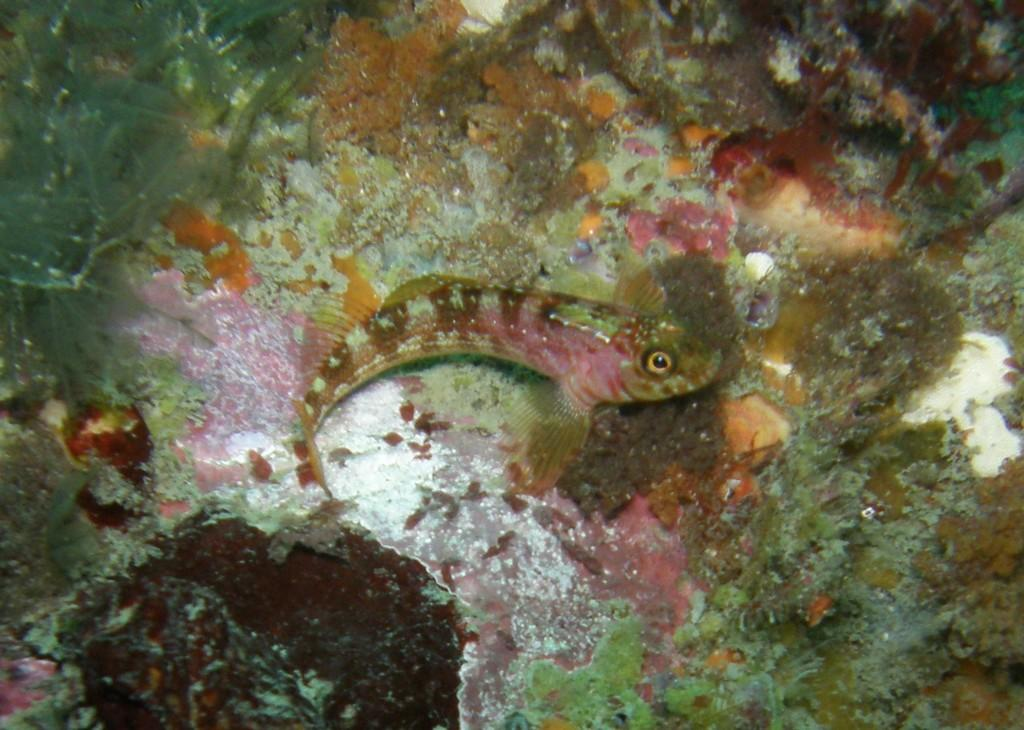What type of environment is shown in the image? The image depicts an underwater environment. Can you describe any specific features of the underwater environment? There is a fish in the middle of the image. What type of sidewalk can be seen in the image? There is no sidewalk present in the image, as it depicts an underwater environment. What type of soup is being prepared in the image? There is no soup being prepared in the image, as it depicts an underwater environment. 